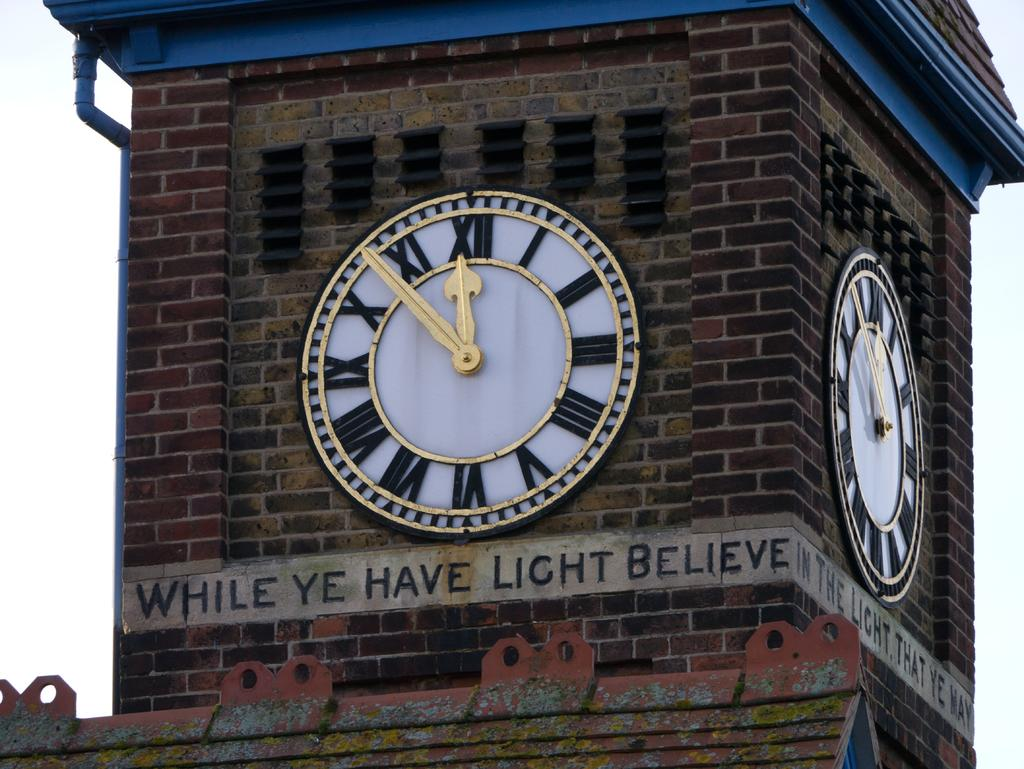<image>
Describe the image concisely. Underneath a large clock, built on to a brick wall is a paraphrased text from the book of John, in the bible regarding believing as long as we have light. 